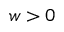<formula> <loc_0><loc_0><loc_500><loc_500>w > 0</formula> 